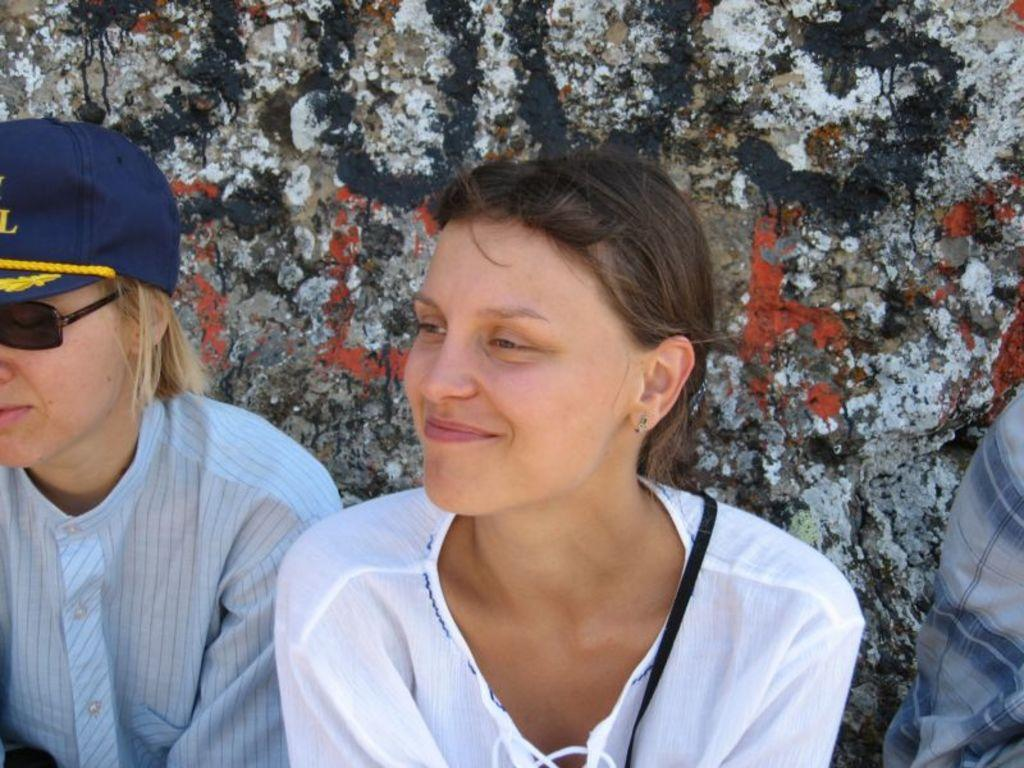How many people are in the image? There are two people in the image. What are the people wearing? Both people are wearing white dresses. Can you describe the headwear of the two people? One person is wearing a blue cap, and the other person is wearing a yellow cap. What can be seen in the background of the image? There is a wall in the background with a different color. What type of crayon is the person with the blue cap holding in the image? There is no crayon present in the image. Can you describe the fangs of the person with the yellow cap in the image? There are no fangs visible on either person in the image. 